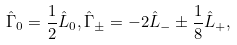<formula> <loc_0><loc_0><loc_500><loc_500>\hat { \Gamma } _ { 0 } = \frac { 1 } { 2 } \hat { L } _ { 0 } , \hat { \Gamma } _ { \pm } = - 2 \hat { L } _ { - } \pm \frac { 1 } { 8 } \hat { L } _ { + } ,</formula> 